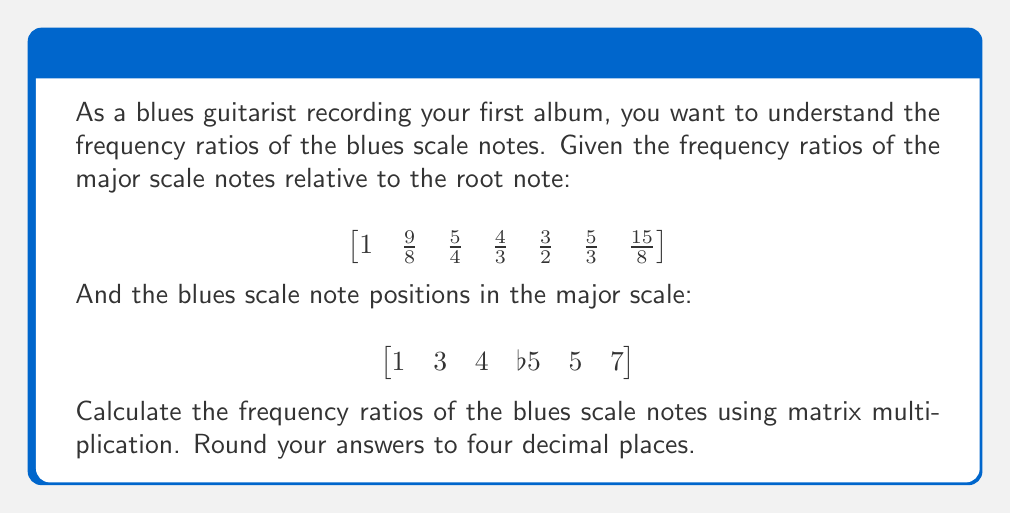Help me with this question. To solve this problem, we'll follow these steps:

1) First, we need to create a matrix that represents the blues scale positions in the major scale. We'll use 1 for included notes and 0 for excluded notes:

$$B = \begin{bmatrix}
1 & 0 & 1 & 1 & 1 & 0 & 1
\end{bmatrix}$$

2) For the flatted fifth (b5), we need to calculate its frequency ratio. It's the geometric mean of the perfect fourth and perfect fifth:

$$b5 = \sqrt{\frac{4}{3} \cdot \frac{3}{2}} = \sqrt{2} = 1.4142$$

3) Now we can create our major scale matrix with the b5 included:

$$M = \begin{bmatrix}
1 & \frac{9}{8} & \frac{5}{4} & \frac{4}{3} & 1.4142 & \frac{3}{2} & \frac{15}{8}
\end{bmatrix}$$

4) To get the blues scale frequency ratios, we multiply these matrices:

$$B \cdot M^T = \begin{bmatrix}
1 & 0 & 1 & 1 & 1 & 0 & 1
\end{bmatrix} \cdot \begin{bmatrix}
1 \\ \frac{9}{8} \\ \frac{5}{4} \\ \frac{4}{3} \\ 1.4142 \\ \frac{3}{2} \\ \frac{15}{8}
\end{bmatrix}$$

5) Performing the multiplication:

$$= 1 \cdot 1 + 0 \cdot \frac{9}{8} + 1 \cdot \frac{5}{4} + 1 \cdot \frac{4}{3} + 1 \cdot 1.4142 + 0 \cdot \frac{3}{2} + 1 \cdot \frac{15}{8}$$

6) Calculating and rounding to four decimal places:

$$= \begin{bmatrix}
1.0000 & 1.2500 & 1.3333 & 1.4142 & 1.5000 & 1.8750
\end{bmatrix}$$

This gives us the frequency ratios for the blues scale notes.
Answer: $$\begin{bmatrix}
1.0000 & 1.2500 & 1.3333 & 1.4142 & 1.5000 & 1.8750
\end{bmatrix}$$ 